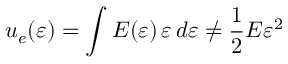<formula> <loc_0><loc_0><loc_500><loc_500>u _ { e } ( \varepsilon ) = \int E ( \varepsilon ) \, \varepsilon \, d \varepsilon \neq { \frac { 1 } { 2 } } E \varepsilon ^ { 2 }</formula> 